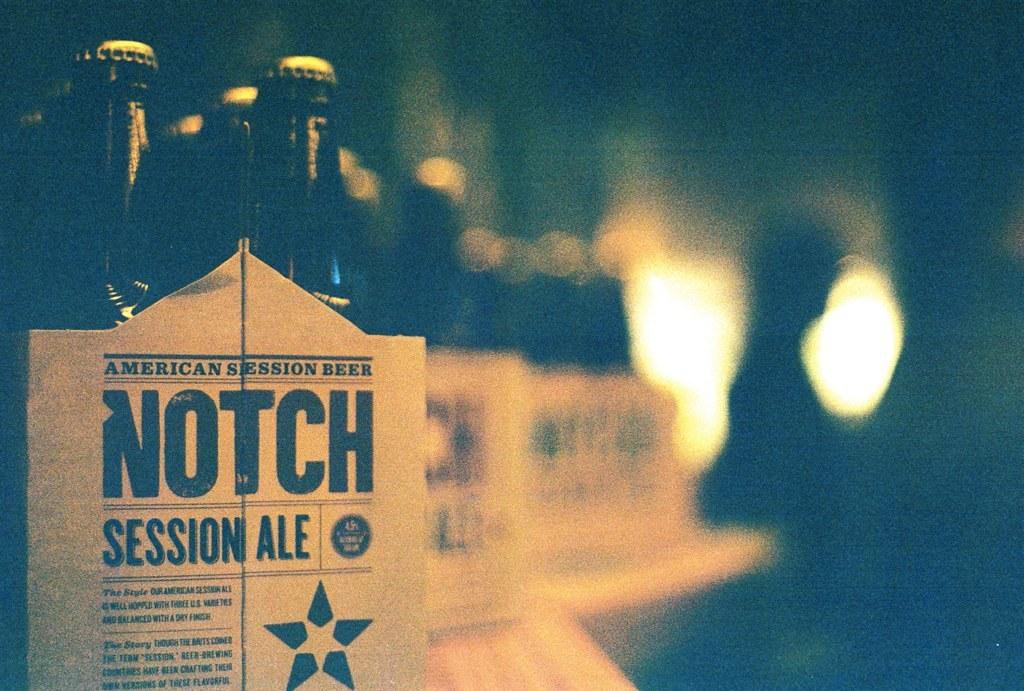What brand of beer is this?
Ensure brevity in your answer.  Notch. What kind of beer is it?
Provide a short and direct response. Session ale. 